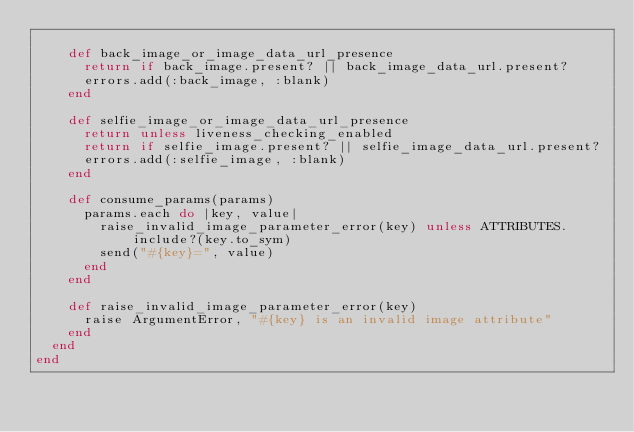Convert code to text. <code><loc_0><loc_0><loc_500><loc_500><_Ruby_>
    def back_image_or_image_data_url_presence
      return if back_image.present? || back_image_data_url.present?
      errors.add(:back_image, :blank)
    end

    def selfie_image_or_image_data_url_presence
      return unless liveness_checking_enabled
      return if selfie_image.present? || selfie_image_data_url.present?
      errors.add(:selfie_image, :blank)
    end

    def consume_params(params)
      params.each do |key, value|
        raise_invalid_image_parameter_error(key) unless ATTRIBUTES.include?(key.to_sym)
        send("#{key}=", value)
      end
    end

    def raise_invalid_image_parameter_error(key)
      raise ArgumentError, "#{key} is an invalid image attribute"
    end
  end
end
</code> 